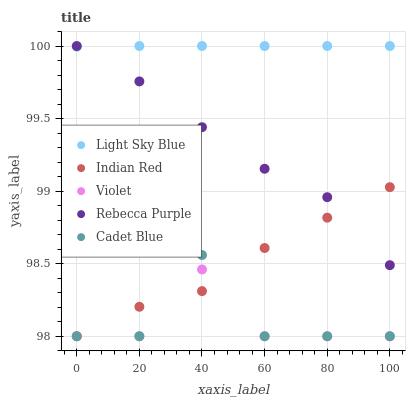Does Violet have the minimum area under the curve?
Answer yes or no. Yes. Does Light Sky Blue have the maximum area under the curve?
Answer yes or no. Yes. Does Rebecca Purple have the minimum area under the curve?
Answer yes or no. No. Does Rebecca Purple have the maximum area under the curve?
Answer yes or no. No. Is Light Sky Blue the smoothest?
Answer yes or no. Yes. Is Cadet Blue the roughest?
Answer yes or no. Yes. Is Rebecca Purple the smoothest?
Answer yes or no. No. Is Rebecca Purple the roughest?
Answer yes or no. No. Does Cadet Blue have the lowest value?
Answer yes or no. Yes. Does Rebecca Purple have the lowest value?
Answer yes or no. No. Does Rebecca Purple have the highest value?
Answer yes or no. Yes. Does Indian Red have the highest value?
Answer yes or no. No. Is Violet less than Rebecca Purple?
Answer yes or no. Yes. Is Rebecca Purple greater than Violet?
Answer yes or no. Yes. Does Violet intersect Cadet Blue?
Answer yes or no. Yes. Is Violet less than Cadet Blue?
Answer yes or no. No. Is Violet greater than Cadet Blue?
Answer yes or no. No. Does Violet intersect Rebecca Purple?
Answer yes or no. No. 